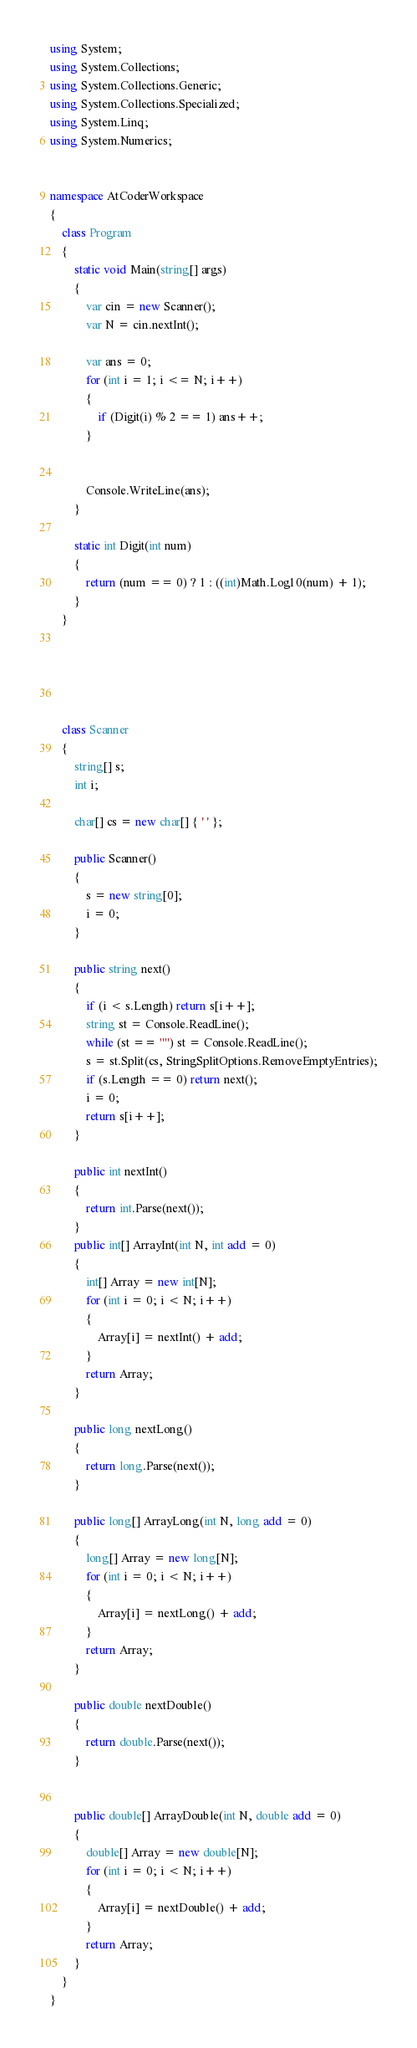Convert code to text. <code><loc_0><loc_0><loc_500><loc_500><_C#_>using System;
using System.Collections;
using System.Collections.Generic;
using System.Collections.Specialized;
using System.Linq;
using System.Numerics;


namespace AtCoderWorkspace
{
    class Program
    {
        static void Main(string[] args)
        {
            var cin = new Scanner();
            var N = cin.nextInt();

            var ans = 0;
            for (int i = 1; i <= N; i++)
            {
                if (Digit(i) % 2 == 1) ans++;
            }
            
            
            Console.WriteLine(ans);
        }

        static int Digit(int num)
        {
            return (num == 0) ? 1 : ((int)Math.Log10(num) + 1);
        }
    }





    class Scanner
    {
        string[] s;
        int i;

        char[] cs = new char[] { ' ' };

        public Scanner()
        {
            s = new string[0];
            i = 0;
        }

        public string next()
        {
            if (i < s.Length) return s[i++];
            string st = Console.ReadLine();
            while (st == "") st = Console.ReadLine();
            s = st.Split(cs, StringSplitOptions.RemoveEmptyEntries);
            if (s.Length == 0) return next();
            i = 0;
            return s[i++];
        }

        public int nextInt()
        {
            return int.Parse(next());
        }
        public int[] ArrayInt(int N, int add = 0)
        {
            int[] Array = new int[N];
            for (int i = 0; i < N; i++)
            {
                Array[i] = nextInt() + add;
            }
            return Array;
        }

        public long nextLong()
        {
            return long.Parse(next());
        }

        public long[] ArrayLong(int N, long add = 0)
        {
            long[] Array = new long[N];
            for (int i = 0; i < N; i++)
            {
                Array[i] = nextLong() + add;
            }
            return Array;
        }

        public double nextDouble()
        {
            return double.Parse(next());
        }


        public double[] ArrayDouble(int N, double add = 0)
        {
            double[] Array = new double[N];
            for (int i = 0; i < N; i++)
            {
                Array[i] = nextDouble() + add;
            }
            return Array;
        }
    }
}
</code> 